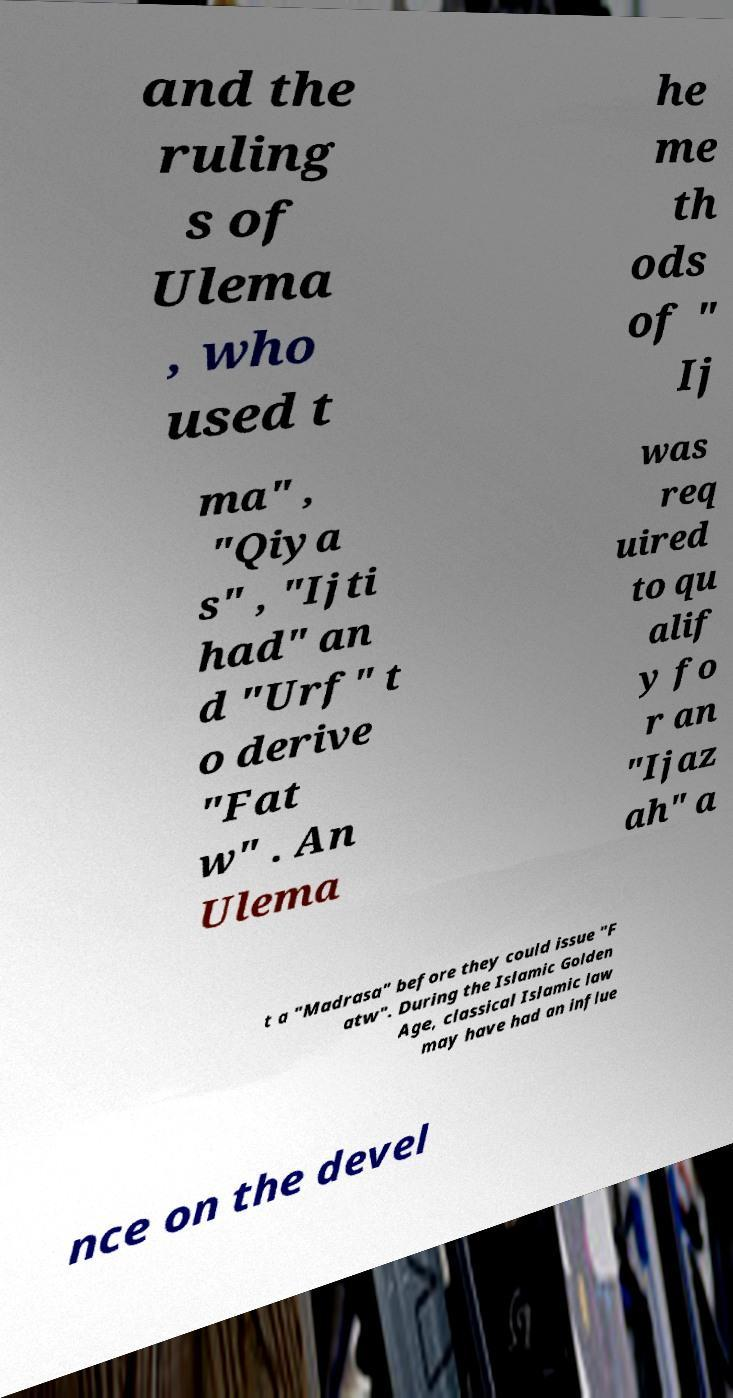Can you accurately transcribe the text from the provided image for me? and the ruling s of Ulema , who used t he me th ods of " Ij ma" , "Qiya s" , "Ijti had" an d "Urf" t o derive "Fat w" . An Ulema was req uired to qu alif y fo r an "Ijaz ah" a t a "Madrasa" before they could issue "F atw". During the Islamic Golden Age, classical Islamic law may have had an influe nce on the devel 